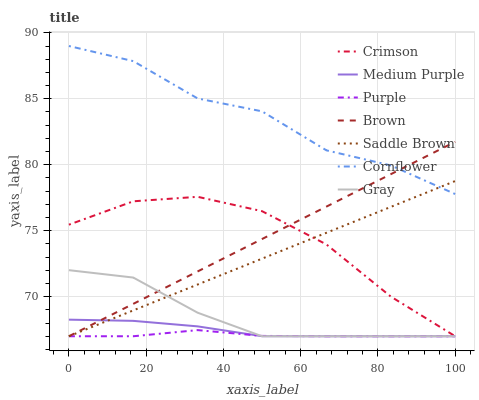Does Purple have the minimum area under the curve?
Answer yes or no. Yes. Does Cornflower have the maximum area under the curve?
Answer yes or no. Yes. Does Brown have the minimum area under the curve?
Answer yes or no. No. Does Brown have the maximum area under the curve?
Answer yes or no. No. Is Brown the smoothest?
Answer yes or no. Yes. Is Cornflower the roughest?
Answer yes or no. Yes. Is Purple the smoothest?
Answer yes or no. No. Is Purple the roughest?
Answer yes or no. No. Does Brown have the lowest value?
Answer yes or no. Yes. Does Cornflower have the highest value?
Answer yes or no. Yes. Does Brown have the highest value?
Answer yes or no. No. Is Crimson less than Cornflower?
Answer yes or no. Yes. Is Cornflower greater than Gray?
Answer yes or no. Yes. Does Gray intersect Brown?
Answer yes or no. Yes. Is Gray less than Brown?
Answer yes or no. No. Is Gray greater than Brown?
Answer yes or no. No. Does Crimson intersect Cornflower?
Answer yes or no. No. 